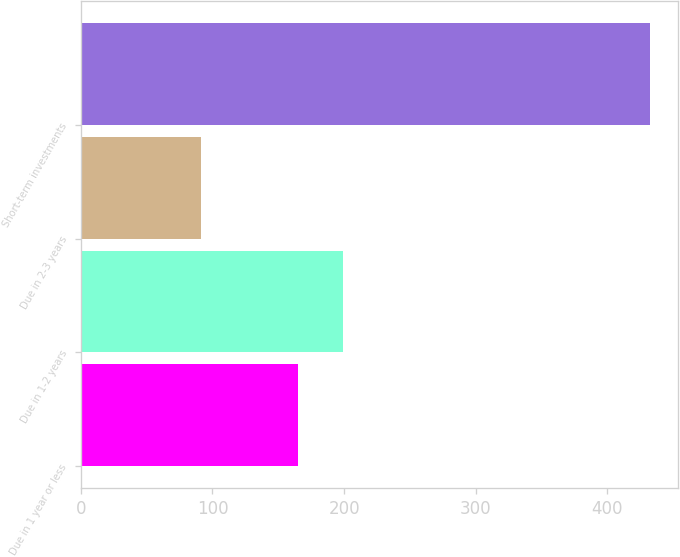<chart> <loc_0><loc_0><loc_500><loc_500><bar_chart><fcel>Due in 1 year or less<fcel>Due in 1-2 years<fcel>Due in 2-3 years<fcel>Short-term investments<nl><fcel>165<fcel>199.1<fcel>91<fcel>432<nl></chart> 